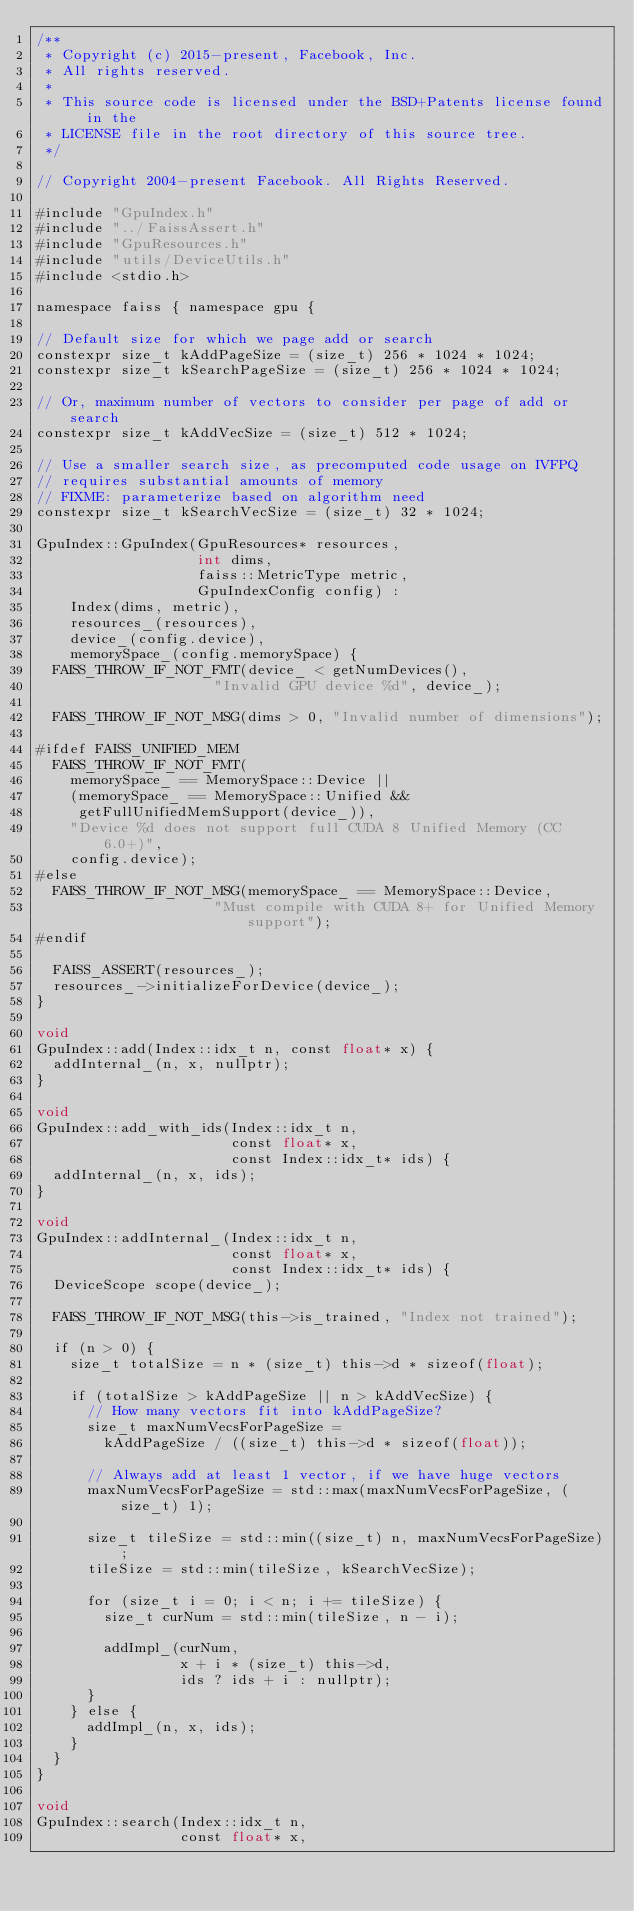<code> <loc_0><loc_0><loc_500><loc_500><_Cuda_>/**
 * Copyright (c) 2015-present, Facebook, Inc.
 * All rights reserved.
 *
 * This source code is licensed under the BSD+Patents license found in the
 * LICENSE file in the root directory of this source tree.
 */

// Copyright 2004-present Facebook. All Rights Reserved.

#include "GpuIndex.h"
#include "../FaissAssert.h"
#include "GpuResources.h"
#include "utils/DeviceUtils.h"
#include <stdio.h>

namespace faiss { namespace gpu {

// Default size for which we page add or search
constexpr size_t kAddPageSize = (size_t) 256 * 1024 * 1024;
constexpr size_t kSearchPageSize = (size_t) 256 * 1024 * 1024;

// Or, maximum number of vectors to consider per page of add or search
constexpr size_t kAddVecSize = (size_t) 512 * 1024;

// Use a smaller search size, as precomputed code usage on IVFPQ
// requires substantial amounts of memory
// FIXME: parameterize based on algorithm need
constexpr size_t kSearchVecSize = (size_t) 32 * 1024;

GpuIndex::GpuIndex(GpuResources* resources,
                   int dims,
                   faiss::MetricType metric,
                   GpuIndexConfig config) :
    Index(dims, metric),
    resources_(resources),
    device_(config.device),
    memorySpace_(config.memorySpace) {
  FAISS_THROW_IF_NOT_FMT(device_ < getNumDevices(),
                     "Invalid GPU device %d", device_);

  FAISS_THROW_IF_NOT_MSG(dims > 0, "Invalid number of dimensions");

#ifdef FAISS_UNIFIED_MEM
  FAISS_THROW_IF_NOT_FMT(
    memorySpace_ == MemorySpace::Device ||
    (memorySpace_ == MemorySpace::Unified &&
     getFullUnifiedMemSupport(device_)),
    "Device %d does not support full CUDA 8 Unified Memory (CC 6.0+)",
    config.device);
#else
  FAISS_THROW_IF_NOT_MSG(memorySpace_ == MemorySpace::Device,
                     "Must compile with CUDA 8+ for Unified Memory support");
#endif

  FAISS_ASSERT(resources_);
  resources_->initializeForDevice(device_);
}

void
GpuIndex::add(Index::idx_t n, const float* x) {
  addInternal_(n, x, nullptr);
}

void
GpuIndex::add_with_ids(Index::idx_t n,
                       const float* x,
                       const Index::idx_t* ids) {
  addInternal_(n, x, ids);
}

void
GpuIndex::addInternal_(Index::idx_t n,
                       const float* x,
                       const Index::idx_t* ids) {
  DeviceScope scope(device_);

  FAISS_THROW_IF_NOT_MSG(this->is_trained, "Index not trained");

  if (n > 0) {
    size_t totalSize = n * (size_t) this->d * sizeof(float);

    if (totalSize > kAddPageSize || n > kAddVecSize) {
      // How many vectors fit into kAddPageSize?
      size_t maxNumVecsForPageSize =
        kAddPageSize / ((size_t) this->d * sizeof(float));

      // Always add at least 1 vector, if we have huge vectors
      maxNumVecsForPageSize = std::max(maxNumVecsForPageSize, (size_t) 1);

      size_t tileSize = std::min((size_t) n, maxNumVecsForPageSize);
      tileSize = std::min(tileSize, kSearchVecSize);

      for (size_t i = 0; i < n; i += tileSize) {
        size_t curNum = std::min(tileSize, n - i);

        addImpl_(curNum,
                 x + i * (size_t) this->d,
                 ids ? ids + i : nullptr);
      }
    } else {
      addImpl_(n, x, ids);
    }
  }
}

void
GpuIndex::search(Index::idx_t n,
                 const float* x,</code> 